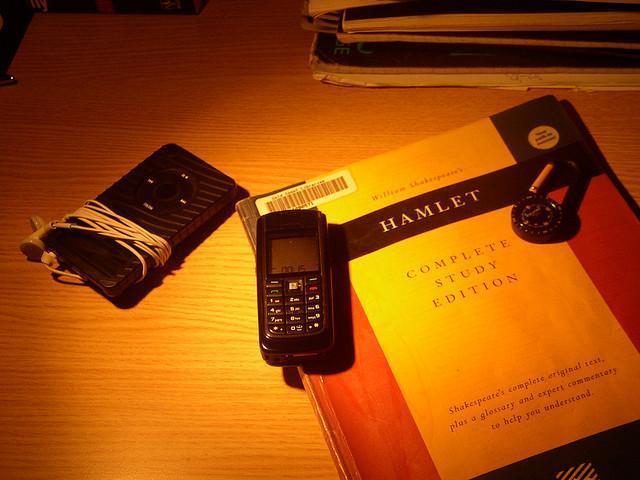How many electronics are in this photo?
Give a very brief answer. 2. How many books are there?
Give a very brief answer. 3. 